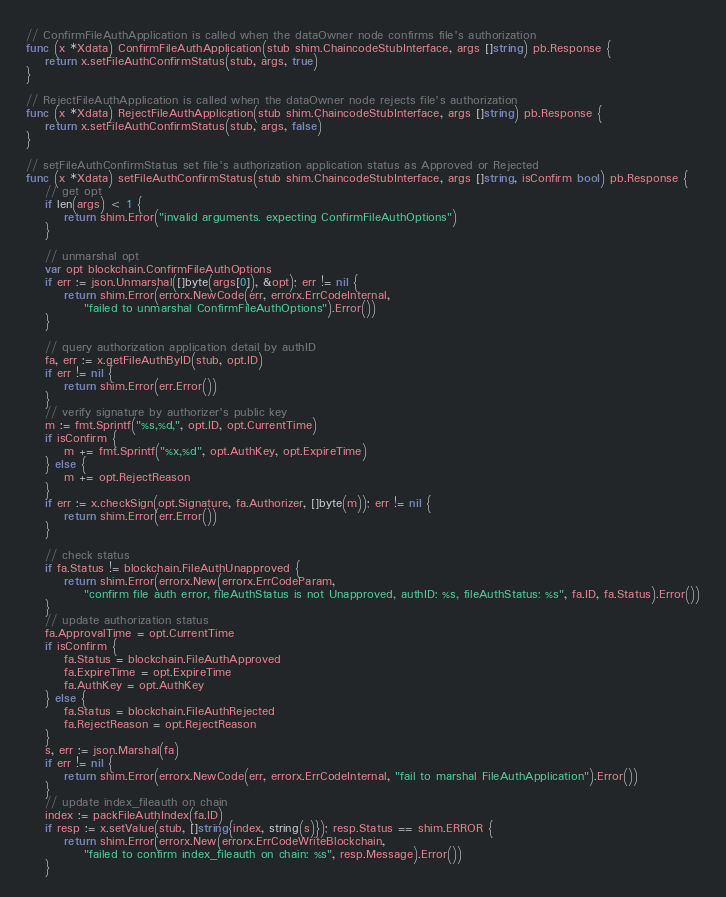Convert code to text. <code><loc_0><loc_0><loc_500><loc_500><_Go_>// ConfirmFileAuthApplication is called when the dataOwner node confirms file's authorization
func (x *Xdata) ConfirmFileAuthApplication(stub shim.ChaincodeStubInterface, args []string) pb.Response {
	return x.setFileAuthConfirmStatus(stub, args, true)
}

// RejectFileAuthApplication is called when the dataOwner node rejects file's authorization
func (x *Xdata) RejectFileAuthApplication(stub shim.ChaincodeStubInterface, args []string) pb.Response {
	return x.setFileAuthConfirmStatus(stub, args, false)
}

// setFileAuthConfirmStatus set file's authorization application status as Approved or Rejected
func (x *Xdata) setFileAuthConfirmStatus(stub shim.ChaincodeStubInterface, args []string, isConfirm bool) pb.Response {
	// get opt
	if len(args) < 1 {
		return shim.Error("invalid arguments. expecting ConfirmFileAuthOptions")
	}

	// unmarshal opt
	var opt blockchain.ConfirmFileAuthOptions
	if err := json.Unmarshal([]byte(args[0]), &opt); err != nil {
		return shim.Error(errorx.NewCode(err, errorx.ErrCodeInternal,
			"failed to unmarshal ConfirmFileAuthOptions").Error())
	}

	// query authorization application detail by authID
	fa, err := x.getFileAuthByID(stub, opt.ID)
	if err != nil {
		return shim.Error(err.Error())
	}
	// verify signature by authorizer's public key
	m := fmt.Sprintf("%s,%d,", opt.ID, opt.CurrentTime)
	if isConfirm {
		m += fmt.Sprintf("%x,%d", opt.AuthKey, opt.ExpireTime)
	} else {
		m += opt.RejectReason
	}
	if err := x.checkSign(opt.Signature, fa.Authorizer, []byte(m)); err != nil {
		return shim.Error(err.Error())
	}

	// check status
	if fa.Status != blockchain.FileAuthUnapproved {
		return shim.Error(errorx.New(errorx.ErrCodeParam,
			"confirm file auth error, fileAuthStatus is not Unapproved, authID: %s, fileAuthStatus: %s", fa.ID, fa.Status).Error())
	}
	// update authorization status
	fa.ApprovalTime = opt.CurrentTime
	if isConfirm {
		fa.Status = blockchain.FileAuthApproved
		fa.ExpireTime = opt.ExpireTime
		fa.AuthKey = opt.AuthKey
	} else {
		fa.Status = blockchain.FileAuthRejected
		fa.RejectReason = opt.RejectReason
	}
	s, err := json.Marshal(fa)
	if err != nil {
		return shim.Error(errorx.NewCode(err, errorx.ErrCodeInternal, "fail to marshal FileAuthApplication").Error())
	}
	// update index_fileauth on chain
	index := packFileAuthIndex(fa.ID)
	if resp := x.setValue(stub, []string{index, string(s)}); resp.Status == shim.ERROR {
		return shim.Error(errorx.New(errorx.ErrCodeWriteBlockchain,
			"failed to confirm index_fileauth on chain: %s", resp.Message).Error())
	}
</code> 